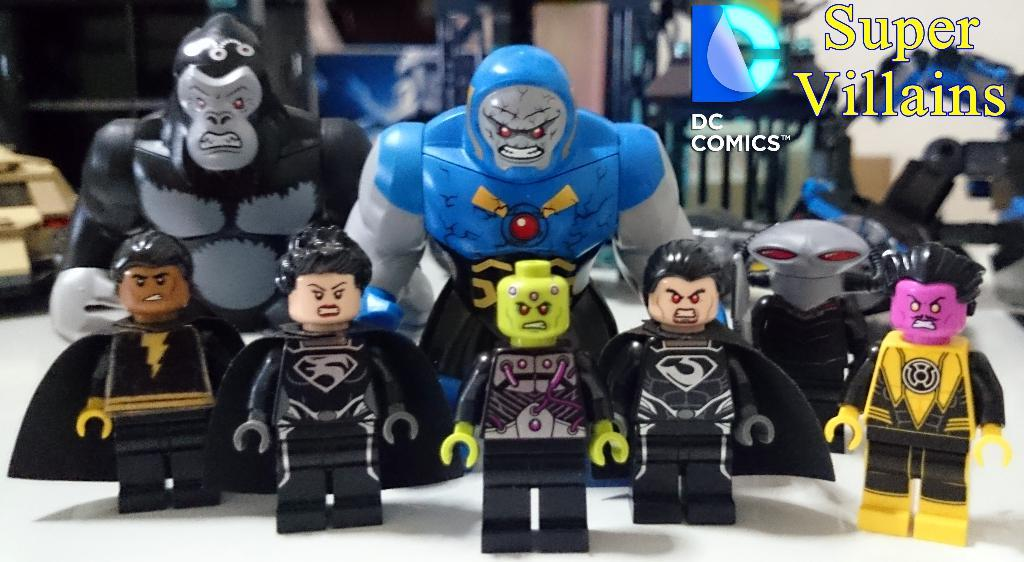What type of objects can be seen in the image? There are toys in the image. What colors are the toys? The toys are in black, yellow, and blue colors. What is the color of the surface on which the toys are placed? The toys are on a white surface. Is there any text or writing visible in the image? Yes, there is text or writing visible in the image. How many men are laughing at the toys in the image? There are no men present in the image, and therefore no one is laughing at the toys. 